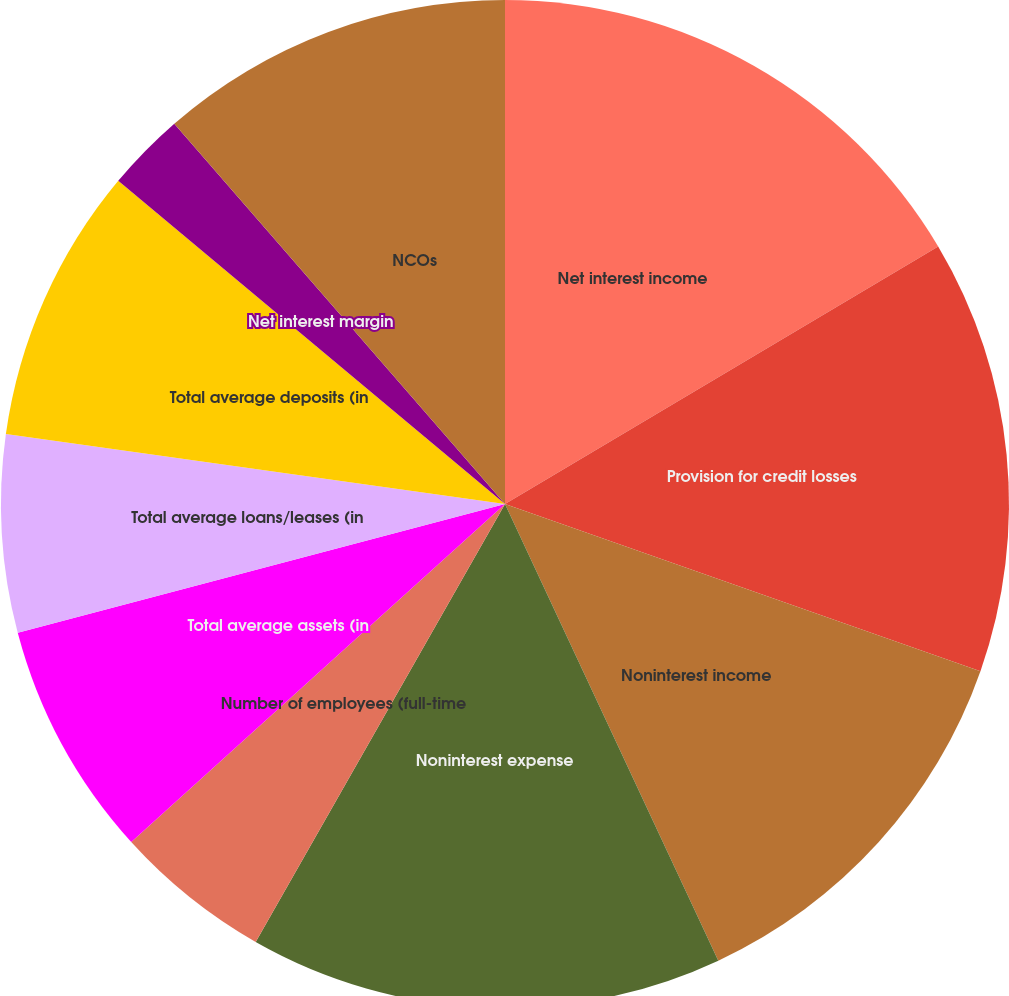Convert chart to OTSL. <chart><loc_0><loc_0><loc_500><loc_500><pie_chart><fcel>Net interest income<fcel>Provision for credit losses<fcel>Noninterest income<fcel>Noninterest expense<fcel>Number of employees (full-time<fcel>Total average assets (in<fcel>Total average loans/leases (in<fcel>Total average deposits (in<fcel>Net interest margin<fcel>NCOs<nl><fcel>16.46%<fcel>13.92%<fcel>12.66%<fcel>15.19%<fcel>5.06%<fcel>7.59%<fcel>6.33%<fcel>8.86%<fcel>2.53%<fcel>11.39%<nl></chart> 